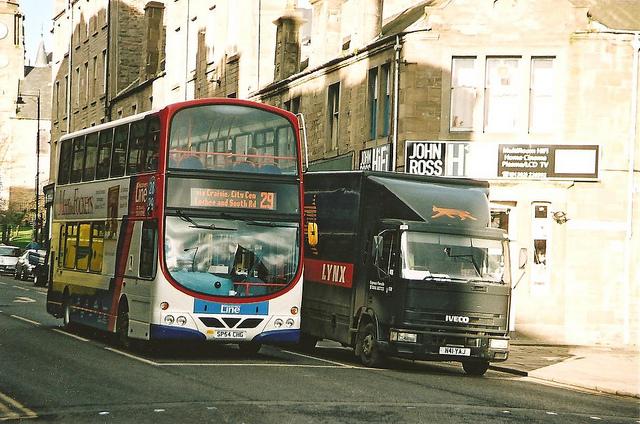What are the vehicles riding on?
Answer briefly. Street. How many levels does the bus have?
Keep it brief. 2. What number is the bus?
Short answer required. 29. 